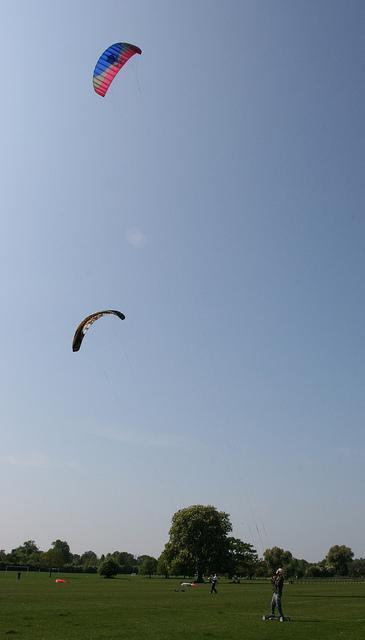How many kites are in the air?
Give a very brief answer. 2. How many kites are pictured?
Give a very brief answer. 2. How many chairs can be seen in this picture?
Give a very brief answer. 0. 